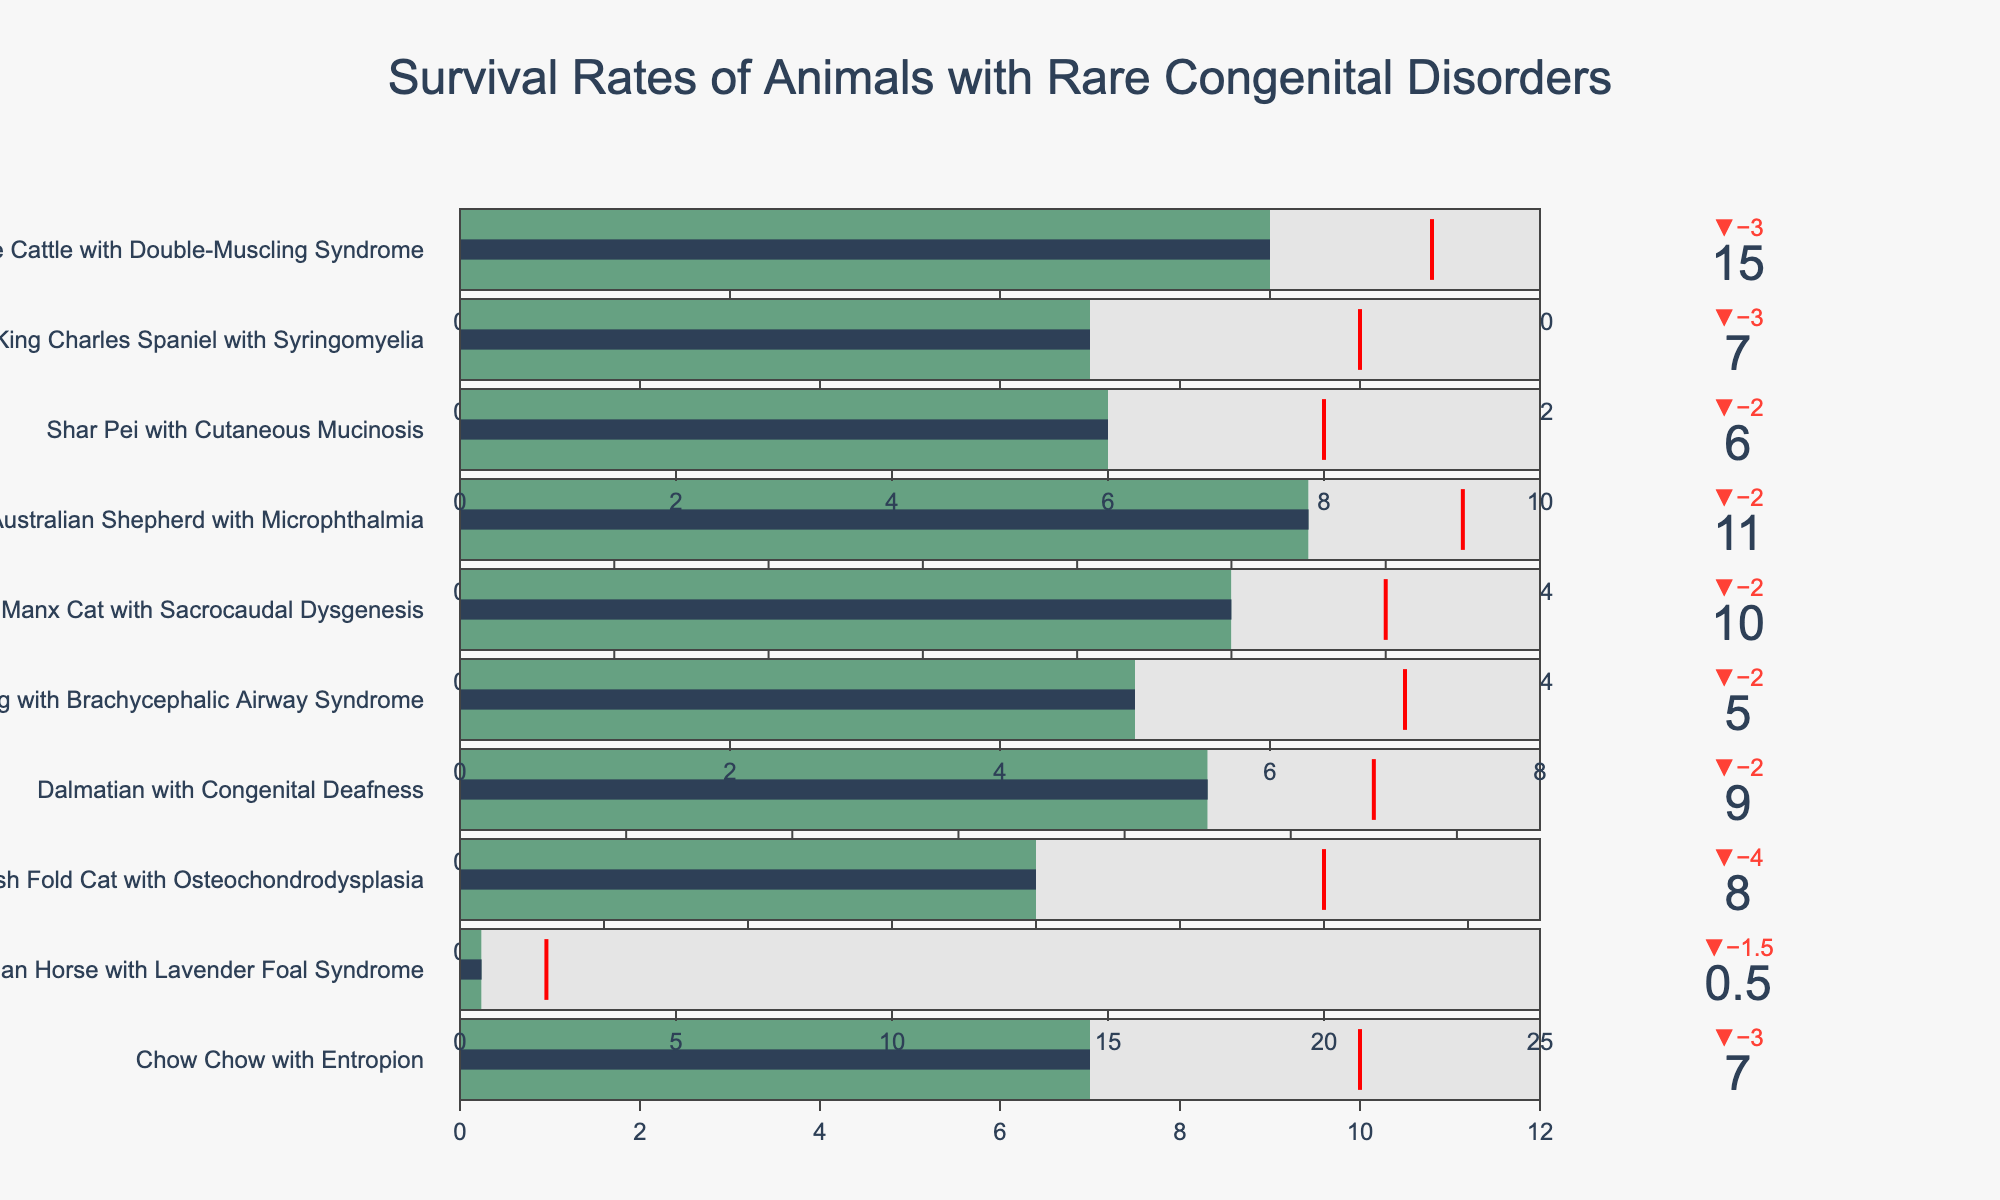What's the survival rate of a Chow Chow with Entropion? The Bullet Chart indicates the current survival rates, with Chow Chow having a specific marker. The title above the bar shows the animal name. The bar provides the exact number.
Answer: 7 years How much more is the target survival rate for a Bulldog with Brachycephalic Airway Syndrome compared to its current survival rate? Identify the Bulldog bar in the chart. The current survival rate is shown in the bar, and the target rate is marked by the red threshold line. Subtract the current from the target.
Answer: 2 years Which animal has the smallest difference between its target survival and typical lifespan? For each bar, compare the lengths indicating the target survival (marked by red threshold line) and typical lifespan (full length of the bar). The Manx Cat has the least difference visually as the red line is closest to the end of the bar.
Answer: Manx Cat Which animal has the highest current survival rate among those listed? Identify the tallest (filled to the rightmost) bar portion, which corresponds to the highest current survival.
Answer: Belgian Blue Cattle What is the median current survival rate for the animals listed? List the current survival rates: [0.5, 5, 6, 7, 7, 8, 9, 10, 11, 15]. The median is the middle number when sorted.
Answer: 7.5 years How far is the current survival rate of a Merle Australian Shepherd with Microphthalmia from its target survival rate in percentage? The Merle Australian Shepherd data includes current (11 years) and target (13 years) survival. Use the formula: ((Target - Current) / Target) * 100.
Answer: 15.38% Which animals have a current survival rate that meets or exceeds their target survival rate? Check all bars to see any bar exceeding or meeting the red threshold line. None meet or exceed the threshold visually.
Answer: None What is the shortest current survival rate among the animals listed? Find the smallest value represented by the filled bar portion on the chart. The lowest value visual is half a year for the Arabian Horse.
Answer: 0.5 years 